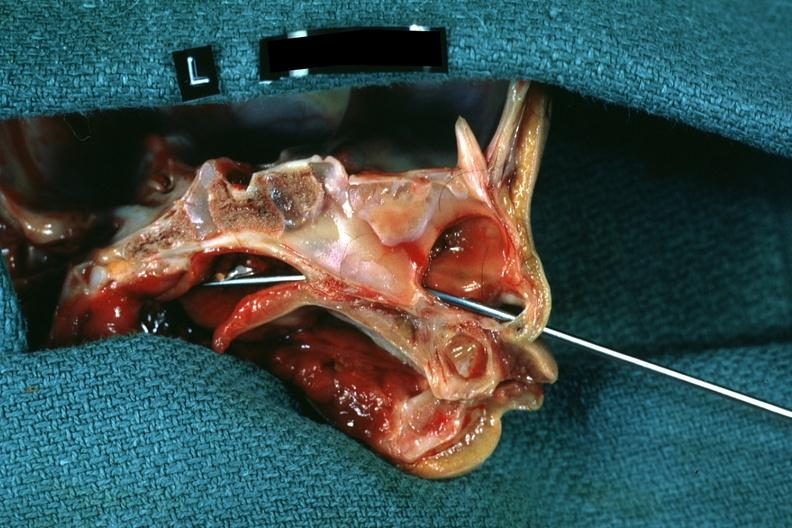what is hemisection of nose left?
Answer the question using a single word or phrase. Side showing patency right side was not patent 